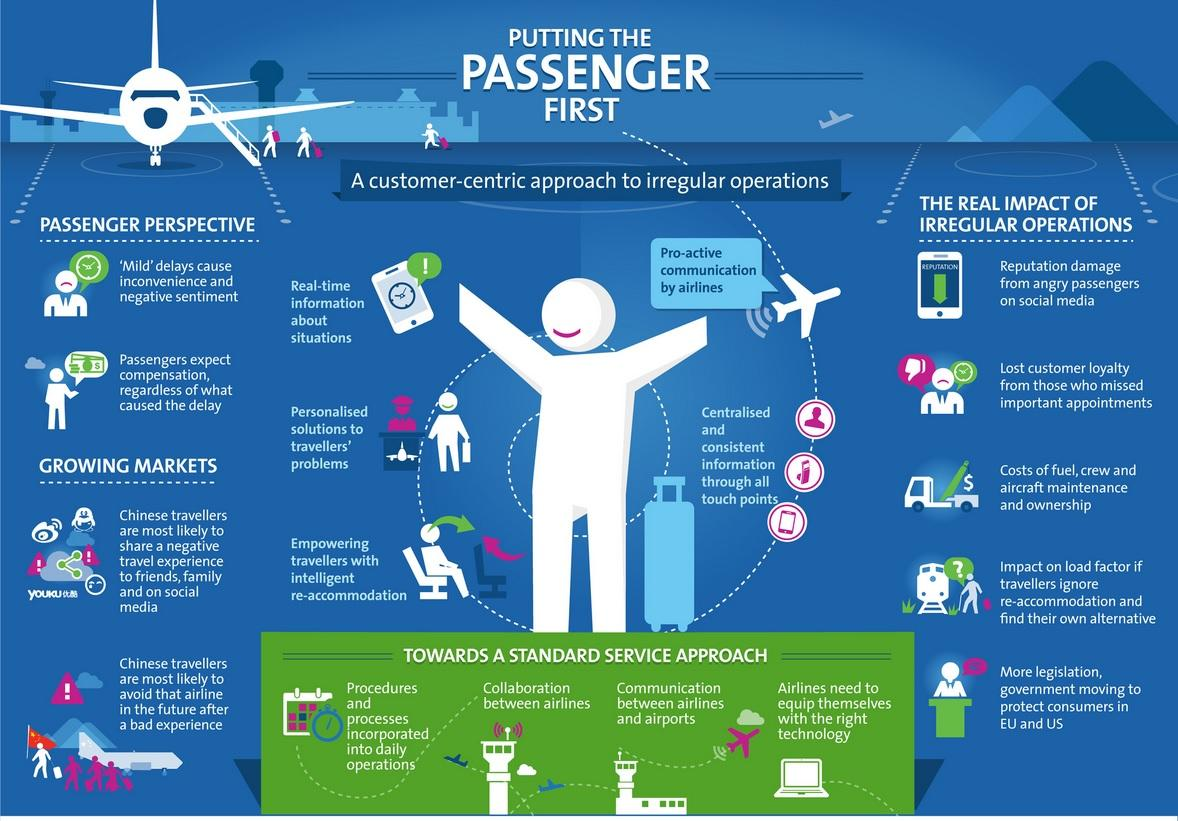Outline some significant characteristics in this image. There are two points under the heading "Passenger Perspective". There are two points under the heading "Growing Markets". 